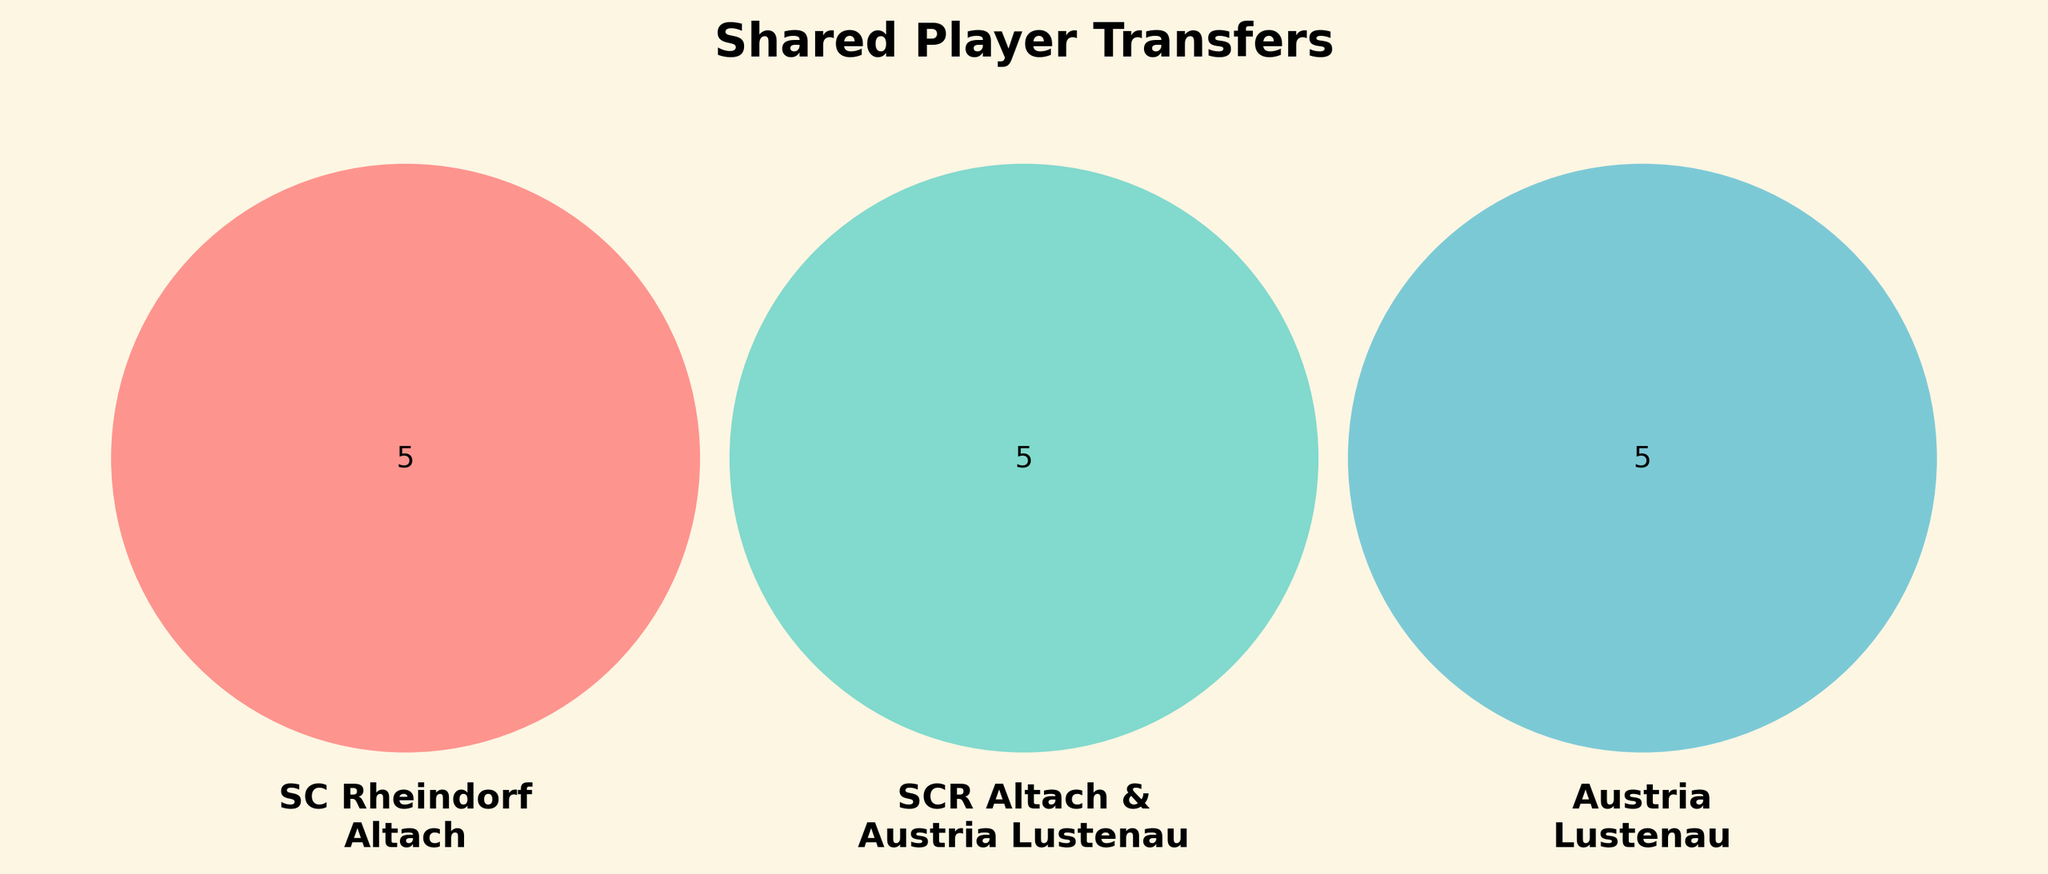What is the main title of the figure? The main title of the figure is located at the top and is usually in bold.
Answer: Shared Player Transfers How many players are exclusively associated with SC Rheindorf Altach? Look at the section of the Venn diagram labeled 'SC Rheindorf Altach' that does not intersect with any other sets. Count the names in that section.
Answer: 6 Which players are shared between SC Rheindorf Altach and Austria Lustenau? Find the intersection area of the Venn diagram shared between 'SC Rheindorf Altach' and 'Austria Lustenau'.
Answer: Emanuel Schreiner Are there any players that are common to all three groups? Check the intersection area where all three circles overlap.
Answer: No What is the total number of players shared between SCR Altach & Austria Lustenau and SC Rheindorf Altach? Sum the players in the intersection between 'SCR Altach & Austria Lustenau' and 'SC Rheindorf Altach'.
Answer: 2 How many players are exclusively associated with Austria Lustenau? Look at the section of the Venn diagram labeled 'Austria Lustenau' that does not intersect with any other sets. Count the names in that section.
Answer: 5 Who are the players not shared between any sets? Look in the areas of each separate circle which do not intersect with any others: count the individuals in each.
Answer: 16 Which club has the least unique players, based on the Venn diagram? Compare the counts of players exclusively mentioned in each club's circle.
Answer: SCR Altach & Austria Lustenau How many players are either in SC Rheindorf Altach or Austria Lustenau but not in the shared group? Count all the players in only the 'SC Rheindorf Altach' and only the 'Austria Lustenau' circles, excluding the shared section.
Answer: 11 Are there more players in the shared section of SCR Altach & Austria Lustenau with SC Rheindorf Altach or Austria Lustenau? Compare the number of players in the overlap sections between SCR Altach & Austria Lustenau with SC Rheindorf Altach and SCR Altach & Austria Lustenau with Austria Lustenau.
Answer: SC Rheindorf Altach 